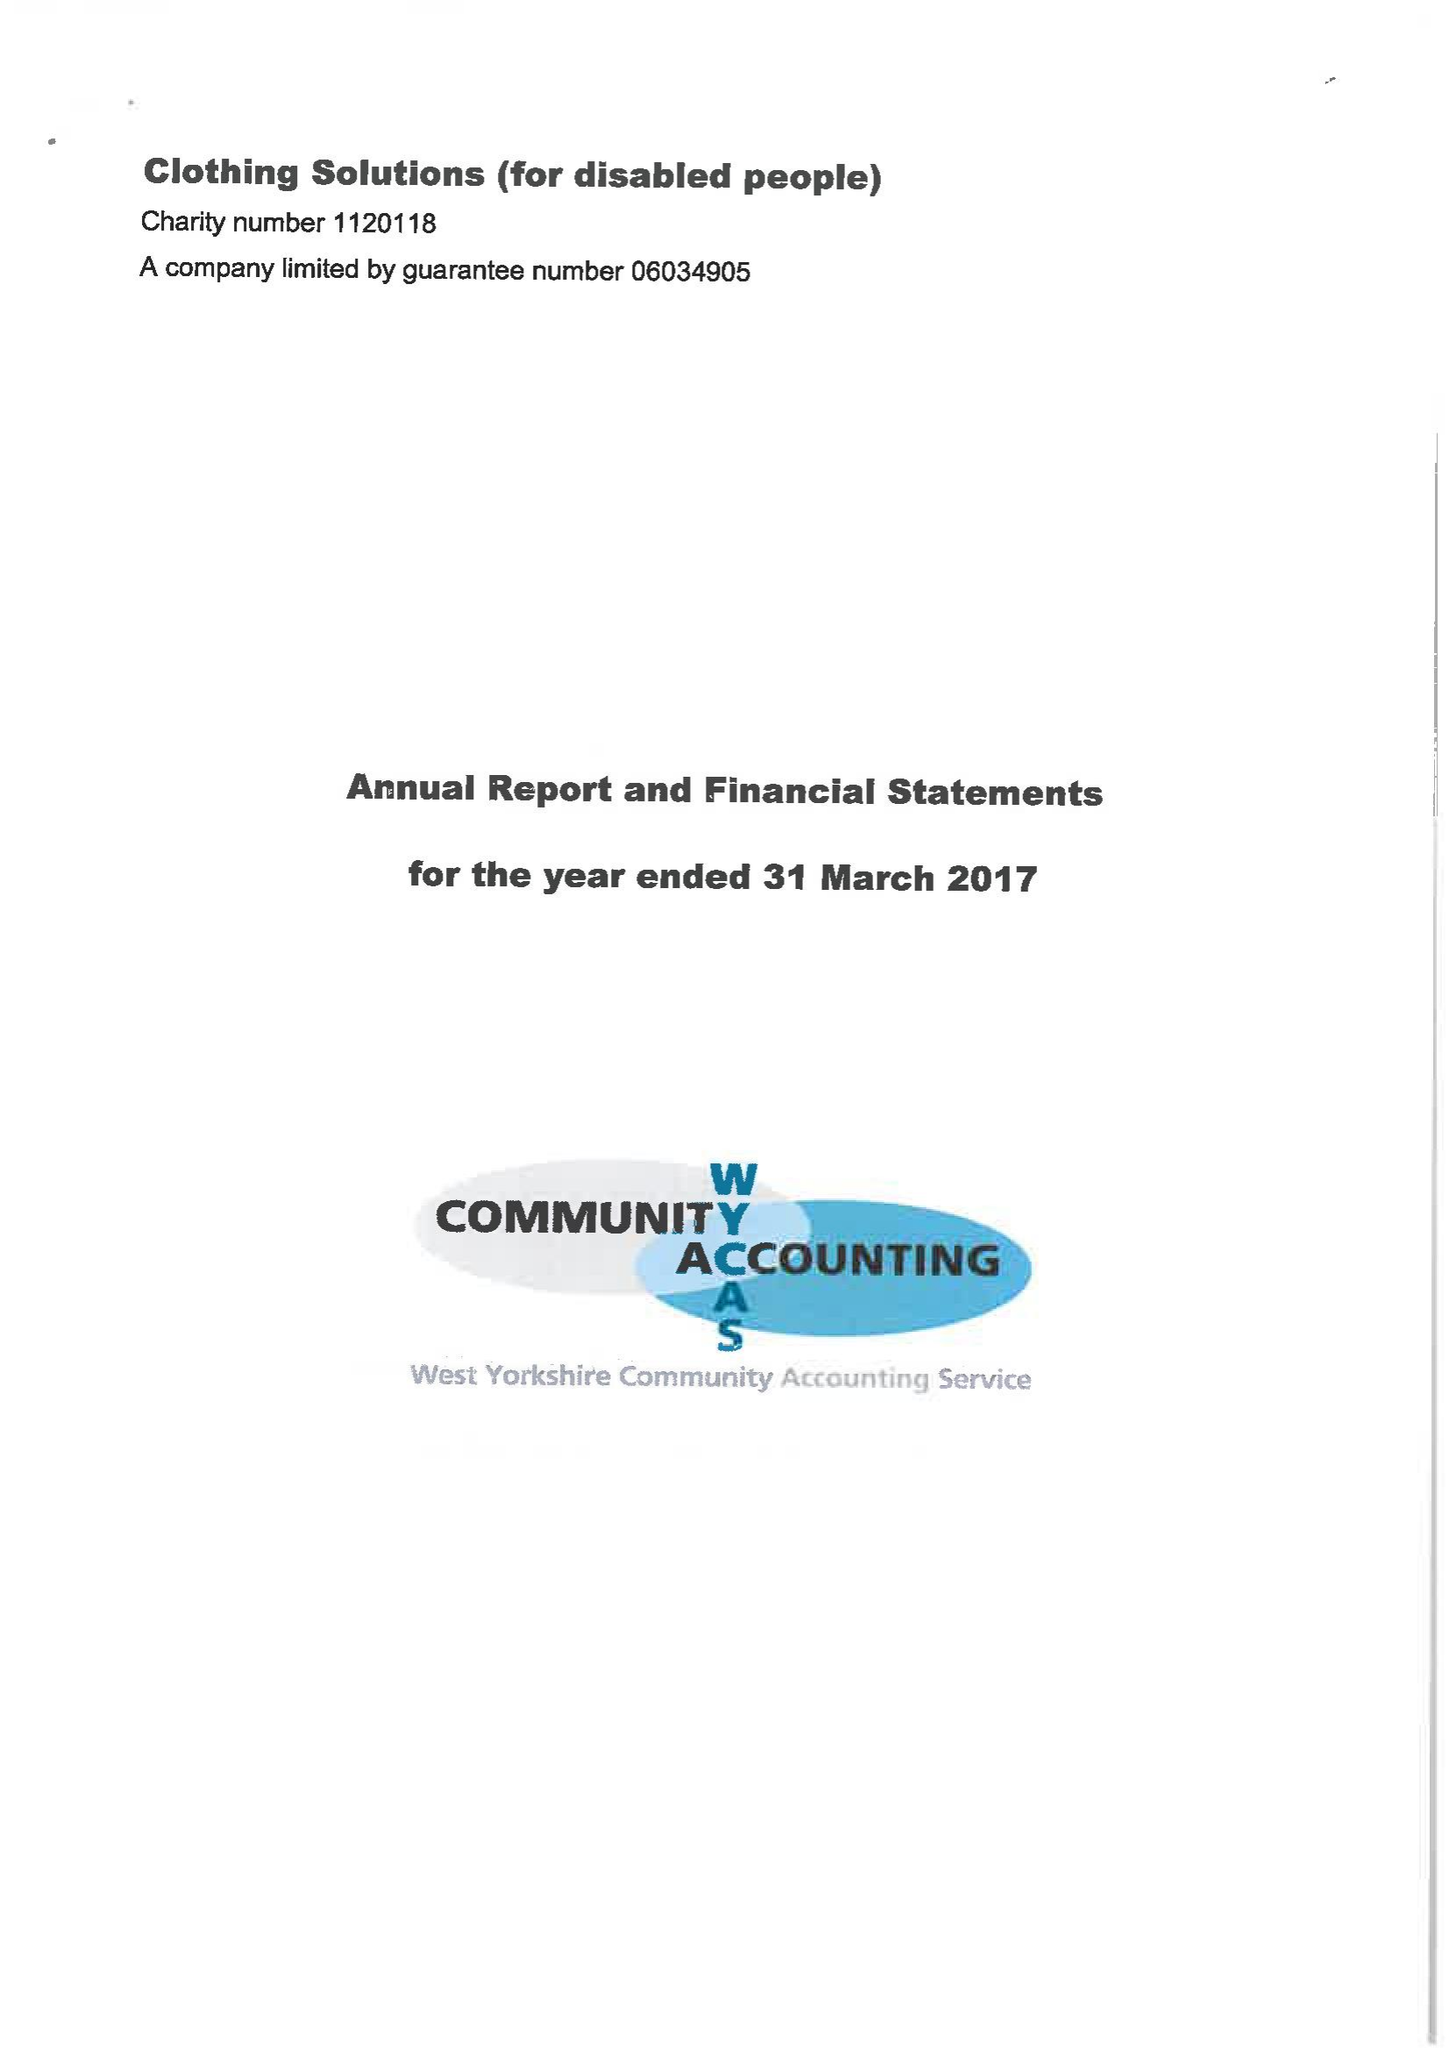What is the value for the charity_name?
Answer the question using a single word or phrase. Clothing Solutions (For Disabled People) 